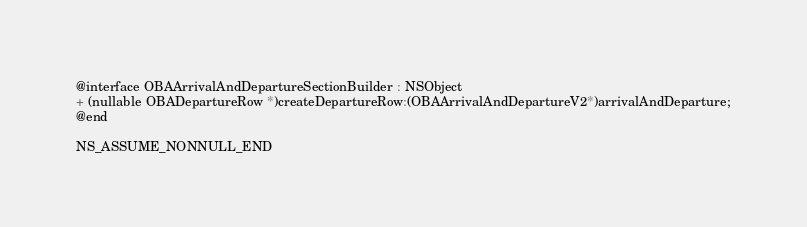<code> <loc_0><loc_0><loc_500><loc_500><_C_>
@interface OBAArrivalAndDepartureSectionBuilder : NSObject
+ (nullable OBADepartureRow *)createDepartureRow:(OBAArrivalAndDepartureV2*)arrivalAndDeparture;
@end

NS_ASSUME_NONNULL_END
</code> 